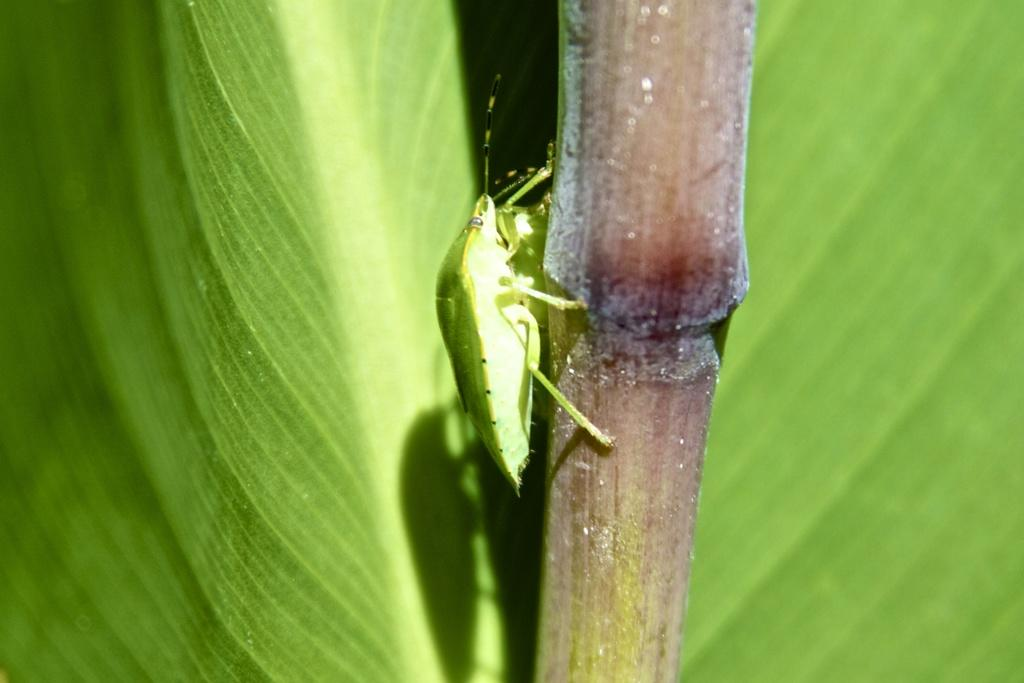What type of creature is present in the image? There is an insect in the image. Where is the insect located? The insect is on a stem. What can be seen in the background of the image? There are leaves in the background of the image. What type of pleasure can be seen in the image? There is no pleasure present in the image; it features an insect on a stem with leaves in the background. Is there a cactus visible in the image? There is no cactus present in the image. 